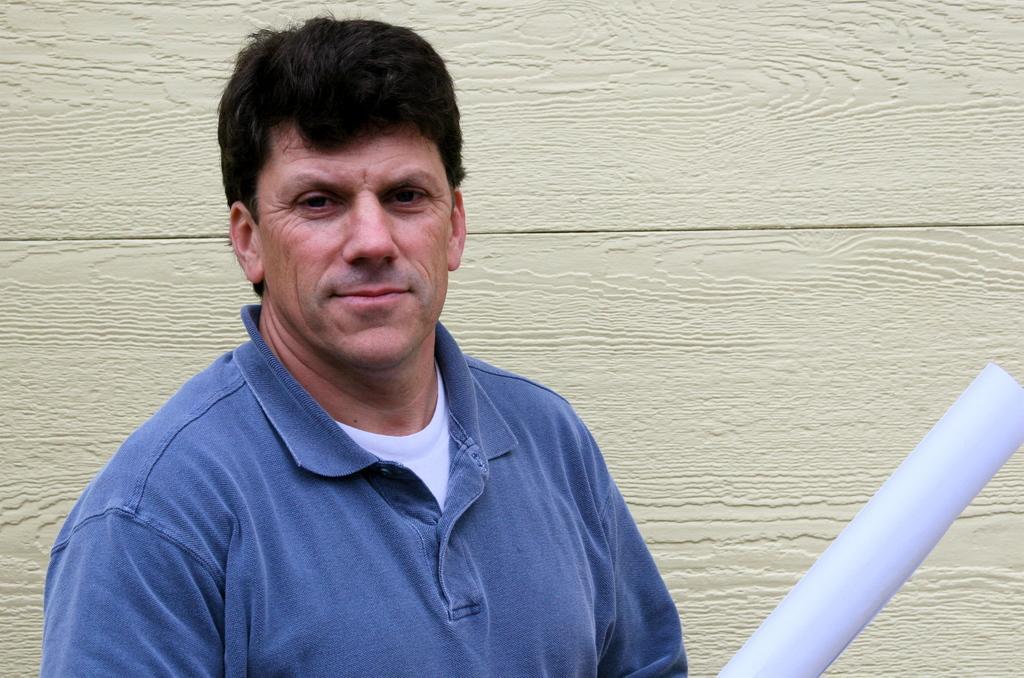Could you give a brief overview of what you see in this image? In this picture we can see an object and a man smiling and in the background we can see the wall. 